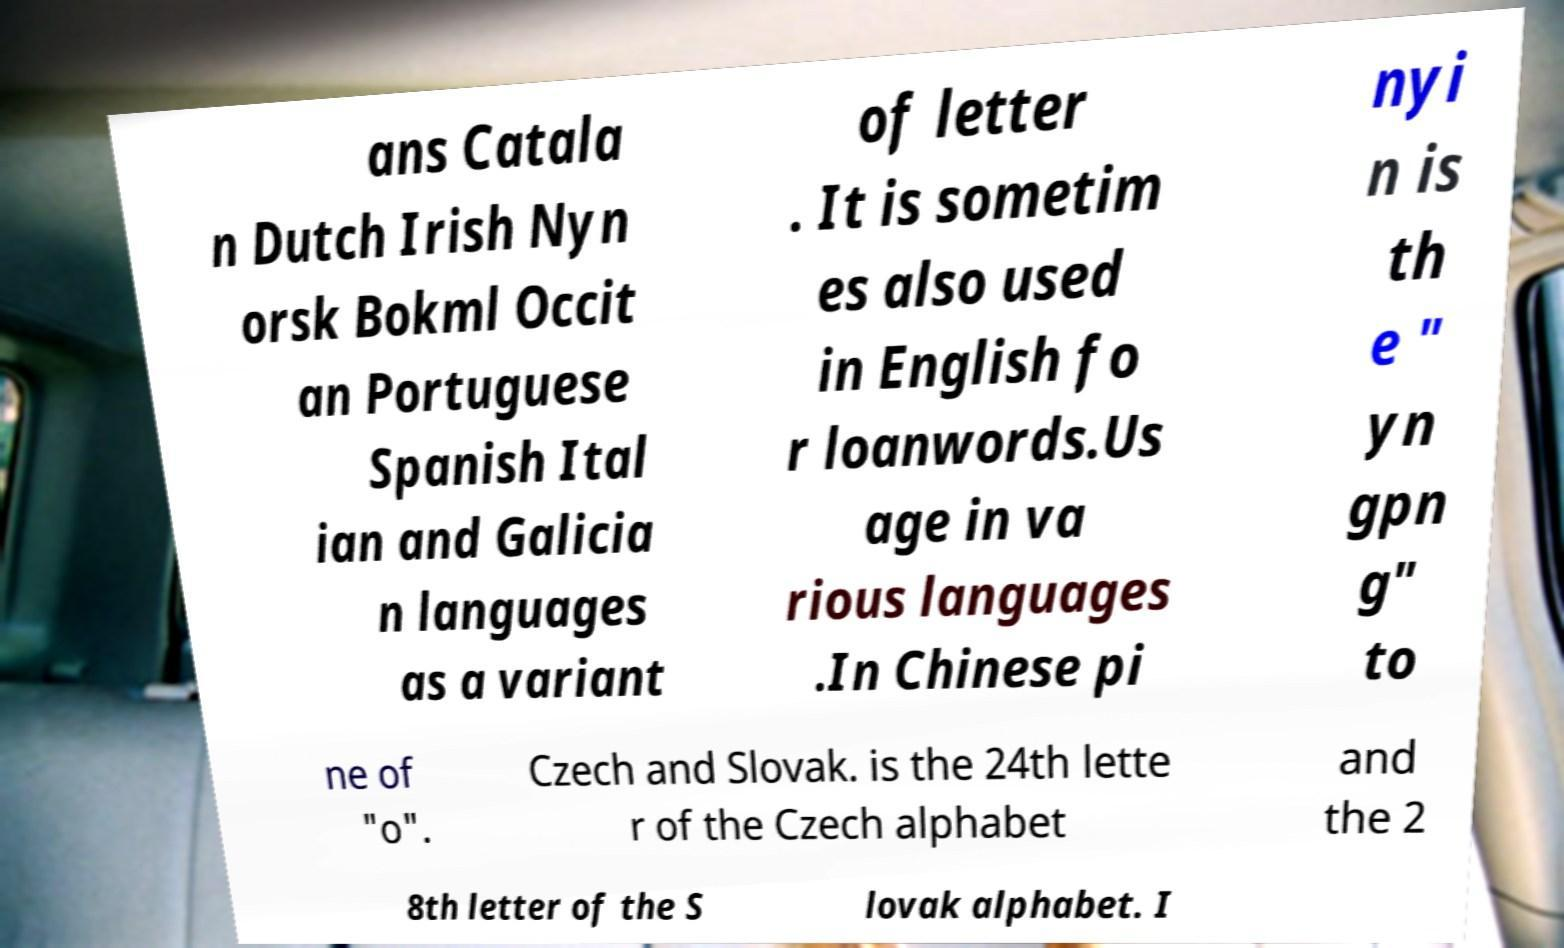Could you extract and type out the text from this image? ans Catala n Dutch Irish Nyn orsk Bokml Occit an Portuguese Spanish Ital ian and Galicia n languages as a variant of letter . It is sometim es also used in English fo r loanwords.Us age in va rious languages .In Chinese pi nyi n is th e " yn gpn g" to ne of "o". Czech and Slovak. is the 24th lette r of the Czech alphabet and the 2 8th letter of the S lovak alphabet. I 